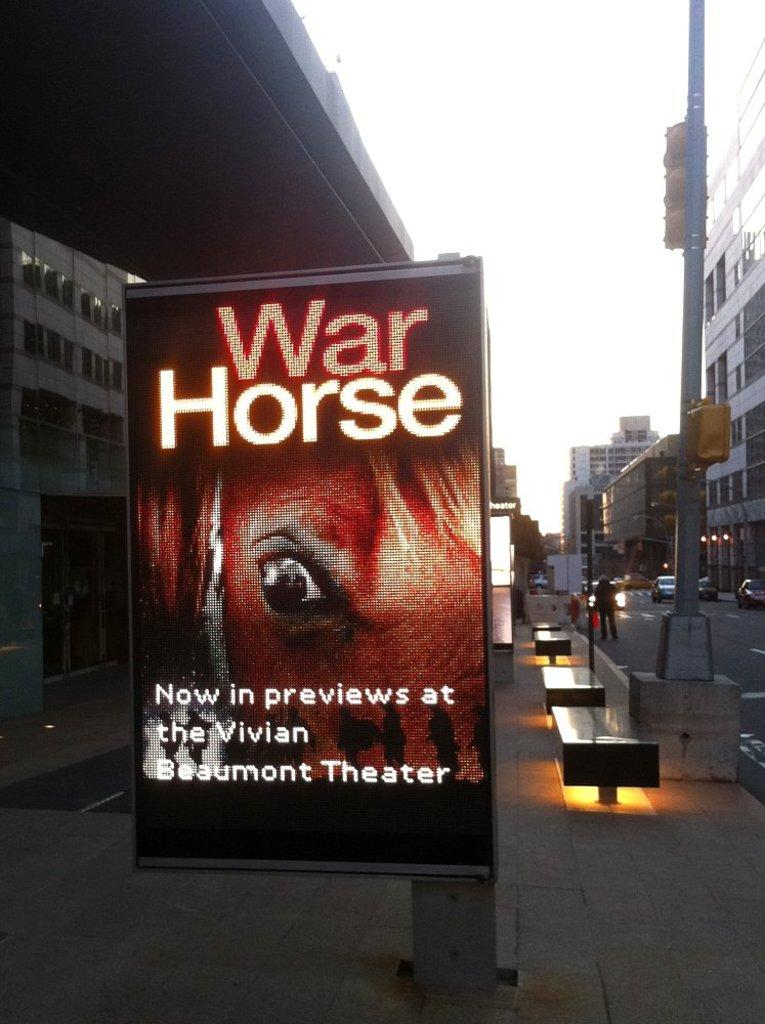<image>
Provide a brief description of the given image. a sign that has the word war horse on it 